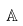<formula> <loc_0><loc_0><loc_500><loc_500>\mathbb { A }</formula> 